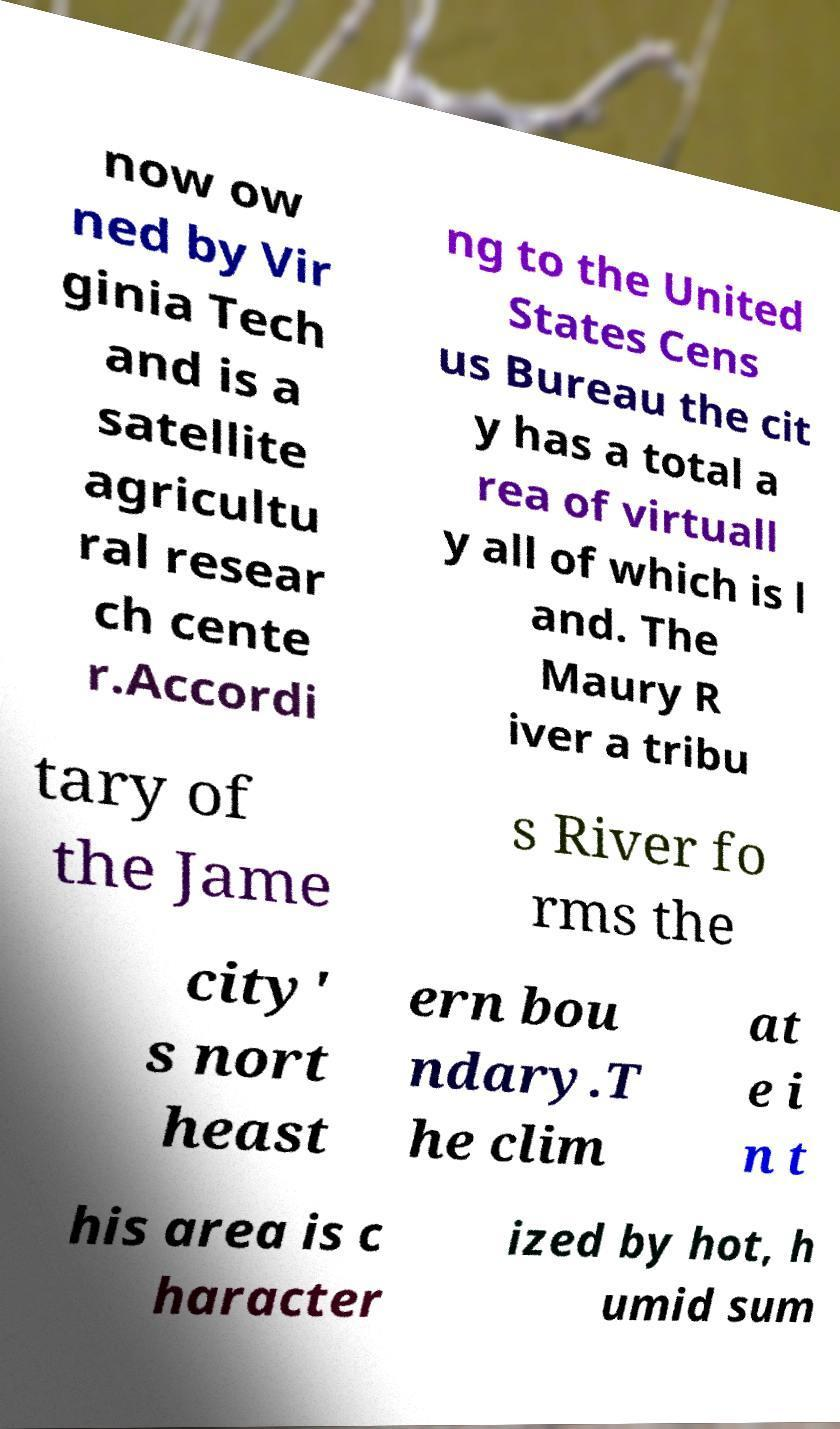Could you assist in decoding the text presented in this image and type it out clearly? now ow ned by Vir ginia Tech and is a satellite agricultu ral resear ch cente r.Accordi ng to the United States Cens us Bureau the cit y has a total a rea of virtuall y all of which is l and. The Maury R iver a tribu tary of the Jame s River fo rms the city' s nort heast ern bou ndary.T he clim at e i n t his area is c haracter ized by hot, h umid sum 